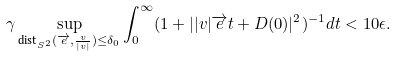<formula> <loc_0><loc_0><loc_500><loc_500>& \gamma \sup _ { \text {dist} _ { S ^ { 2 } } ( \overrightarrow { e } , \frac { v } { | v | } ) \leq \delta _ { 0 } } \int _ { 0 } ^ { \infty } ( 1 + | | v | \overrightarrow { e } t + D ( 0 ) | ^ { 2 } ) ^ { - 1 } d t < 1 0 \epsilon .</formula> 